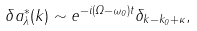Convert formula to latex. <formula><loc_0><loc_0><loc_500><loc_500>\delta a _ { \lambda } ^ { * } ( k ) \sim e ^ { - i ( \Omega - \omega _ { 0 } ) t } \delta _ { k - k _ { 0 } + \kappa } ,</formula> 